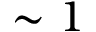Convert formula to latex. <formula><loc_0><loc_0><loc_500><loc_500>\sim 1</formula> 